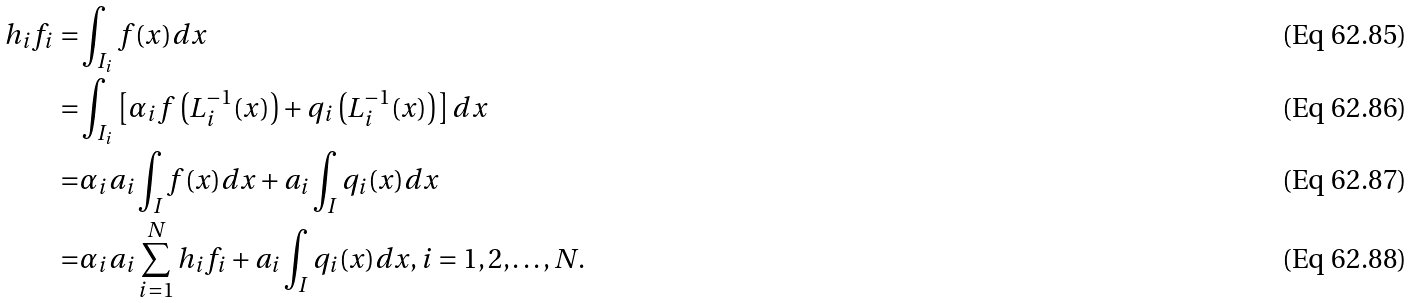Convert formula to latex. <formula><loc_0><loc_0><loc_500><loc_500>h _ { i } f _ { i } = & \int _ { I _ { i } } f ( x ) d x \\ = & \int _ { I _ { i } } \left [ \alpha _ { i } f \left ( L _ { i } ^ { - 1 } ( x ) \right ) + q _ { i } \left ( L _ { i } ^ { - 1 } ( x ) \right ) \right ] d x \\ = & \alpha _ { i } a _ { i } \int _ { I } f ( x ) d x + a _ { i } \int _ { I } q _ { i } ( x ) d x \\ = & \alpha _ { i } a _ { i } \sum _ { i = 1 } ^ { N } h _ { i } f _ { i } + a _ { i } \int _ { I } q _ { i } ( x ) d x , i = 1 , 2 , \dots , N .</formula> 